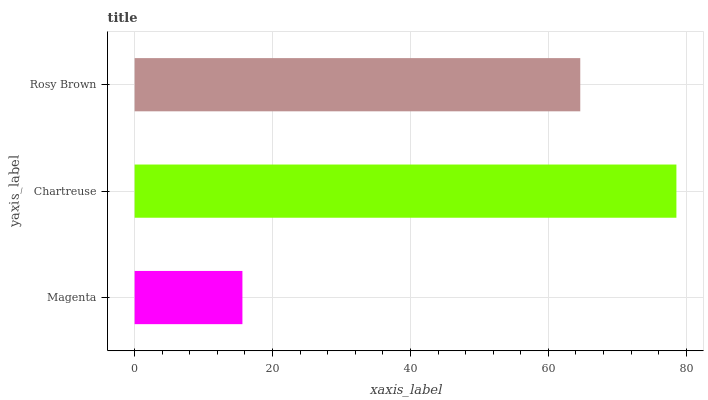Is Magenta the minimum?
Answer yes or no. Yes. Is Chartreuse the maximum?
Answer yes or no. Yes. Is Rosy Brown the minimum?
Answer yes or no. No. Is Rosy Brown the maximum?
Answer yes or no. No. Is Chartreuse greater than Rosy Brown?
Answer yes or no. Yes. Is Rosy Brown less than Chartreuse?
Answer yes or no. Yes. Is Rosy Brown greater than Chartreuse?
Answer yes or no. No. Is Chartreuse less than Rosy Brown?
Answer yes or no. No. Is Rosy Brown the high median?
Answer yes or no. Yes. Is Rosy Brown the low median?
Answer yes or no. Yes. Is Magenta the high median?
Answer yes or no. No. Is Chartreuse the low median?
Answer yes or no. No. 